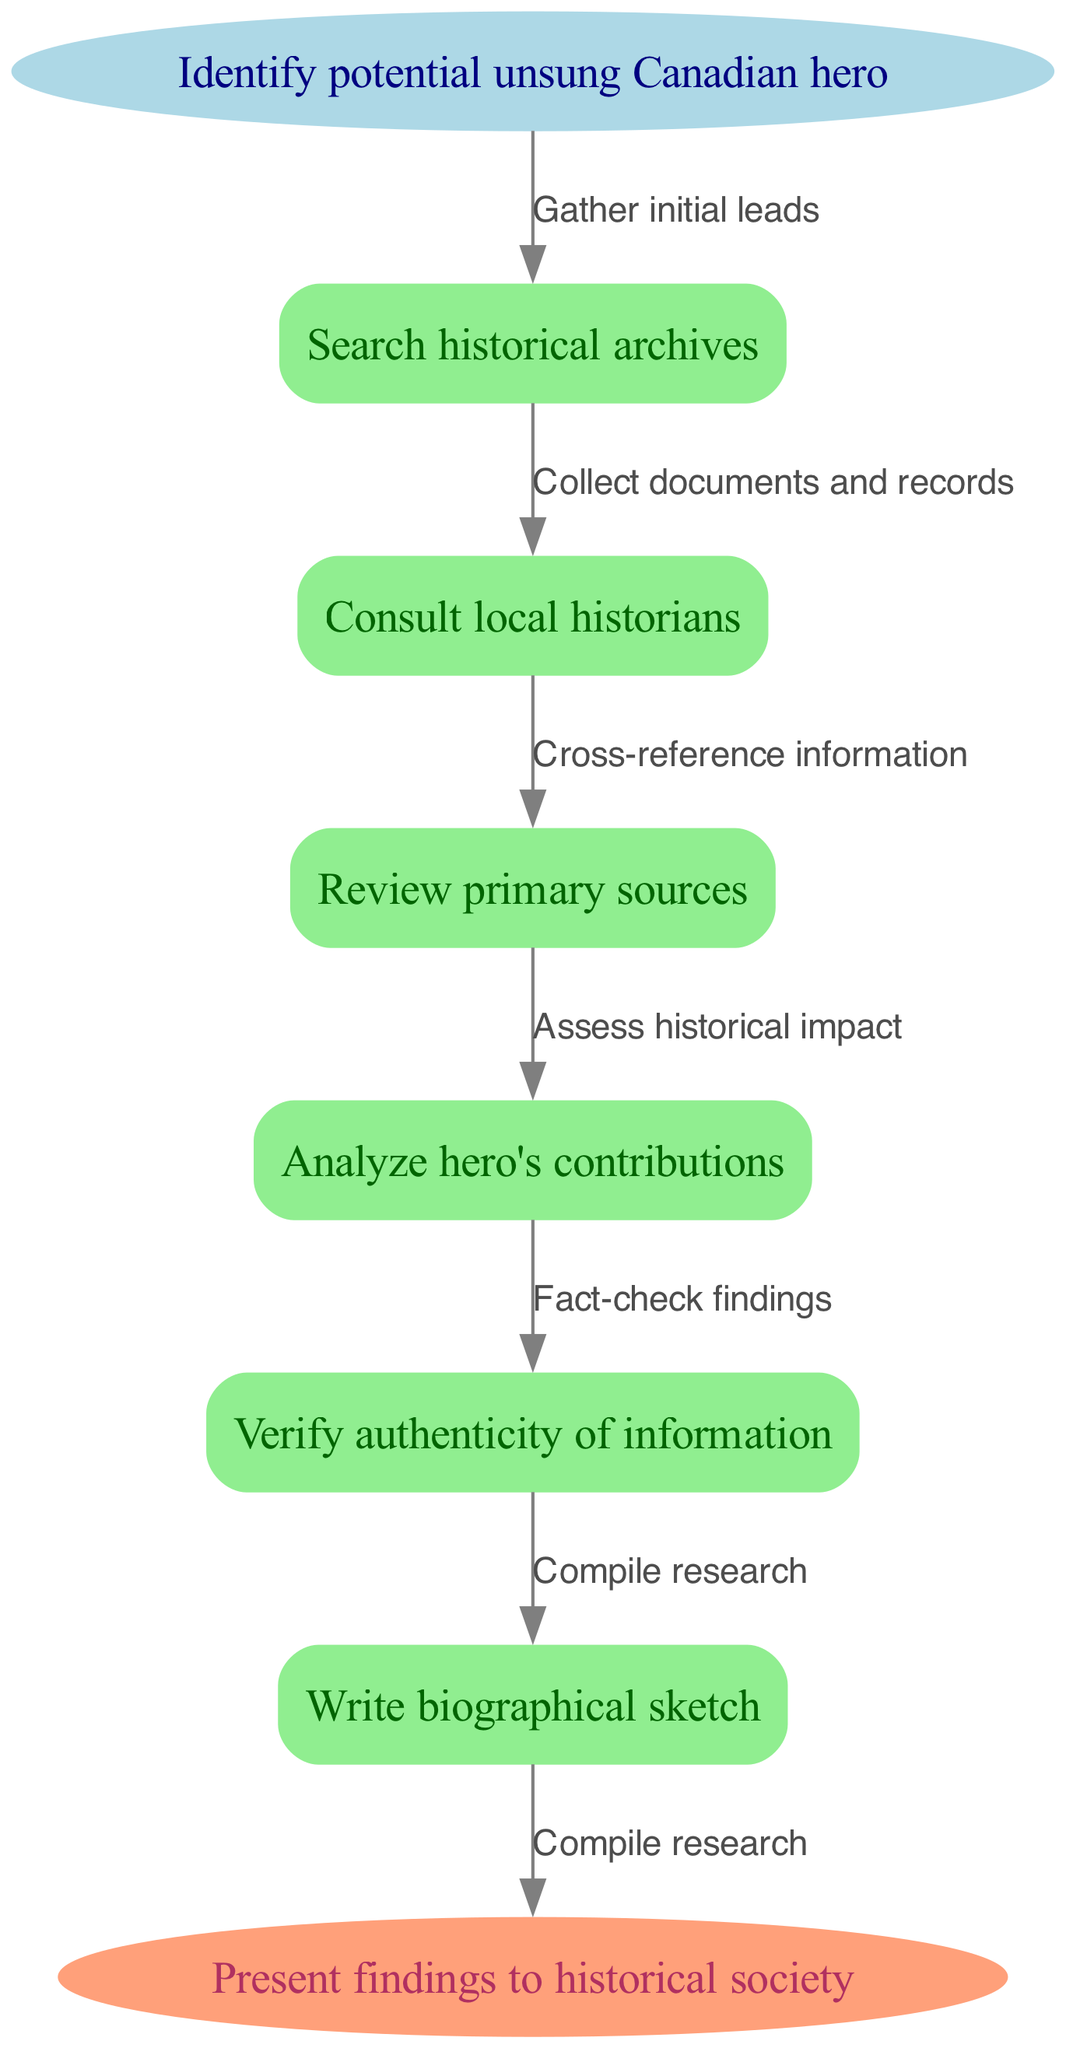What is the start node in the diagram? The start node is explicitly labeled, showing the first step in the process, which is “Identify potential unsung Canadian hero.”
Answer: Identify potential unsung Canadian hero How many nodes are there in total? Counting the start and end nodes along with the intermediate nodes, there are 7 nodes in total: 1 start, 5 intermediate, and 1 end node.
Answer: 7 What is the last action before presenting the findings? The last action before reaching the end is “Compile research,” which is indicated as the connection to the end node.
Answer: Compile research What is the relationship between "Search historical archives" and "Review primary sources"? The edge connecting these two nodes is the label "Collect documents and records," indicating that reviewing primary sources follows searching historical archives.
Answer: Collect documents and records What is the final step in the process? The end node clearly states the last step in this flowchart is “Present findings to historical society,” indicating the ultimate goal of the research process.
Answer: Present findings to historical society Which node analyzes the hero's contributions? The node labeled “Analyze hero's contributions” specifically revolves around assessing the impact of the hero’s actions, making it a crucial step in the process.
Answer: Analyze hero's contributions How do you verify the authenticity of the information gathered from “Consult local historians”? After consulting local historians, you must cross-reference the information, as indicated by the edges in the flowchart that describe the relationships between nodes.
Answer: Cross-reference information List two actions that follow the initial identification of a potential hero. The actions following the initial step include “Search historical archives” and “Consult local historians,” showing the next steps in the research process.
Answer: Search historical archives, Consult local historians 